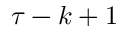<formula> <loc_0><loc_0><loc_500><loc_500>\tau - k + 1</formula> 